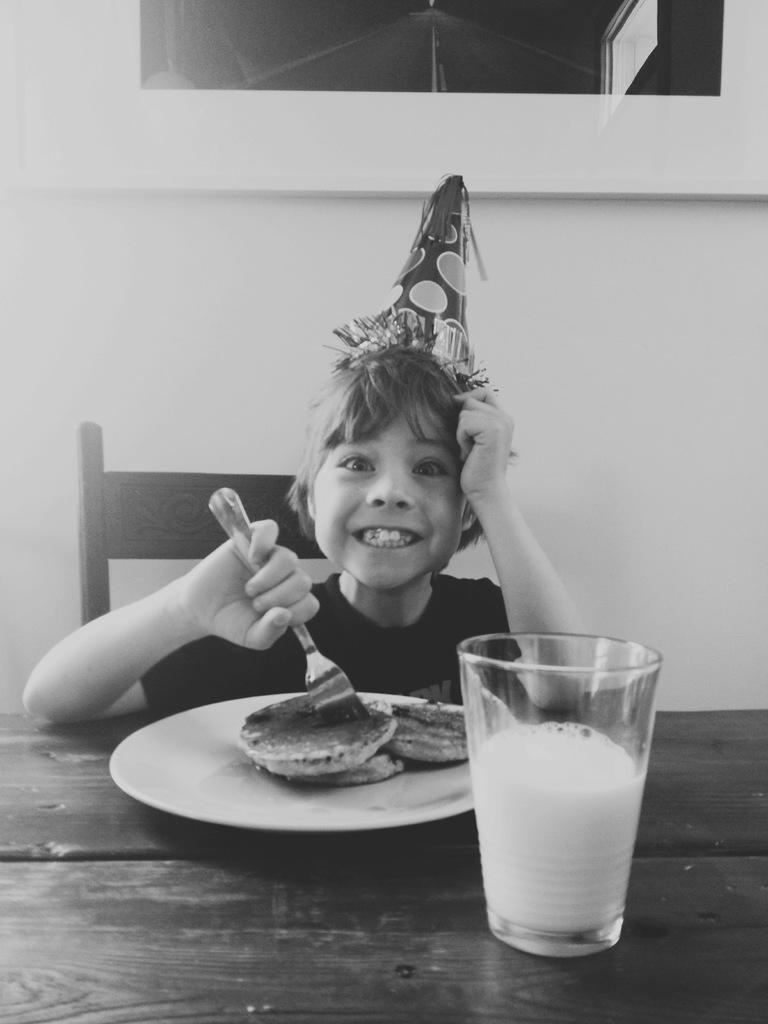What is the main subject of the image? The main subject of the image is a kid. What is the kid doing in the image? The kid is sitting in a chair. What is on the table in front of the kid? There are pancakes and a glass of milk on the table. What can be seen in the background of the image? There is a white wall in the background of the image. How many eyes can be seen on the kid's toe in the image? There are no visible eyes on the kid's toe in the image. What rule is being enforced by the pancakes on the table? There is no rule being enforced by the pancakes in the image; they are simply a food item on the table. 